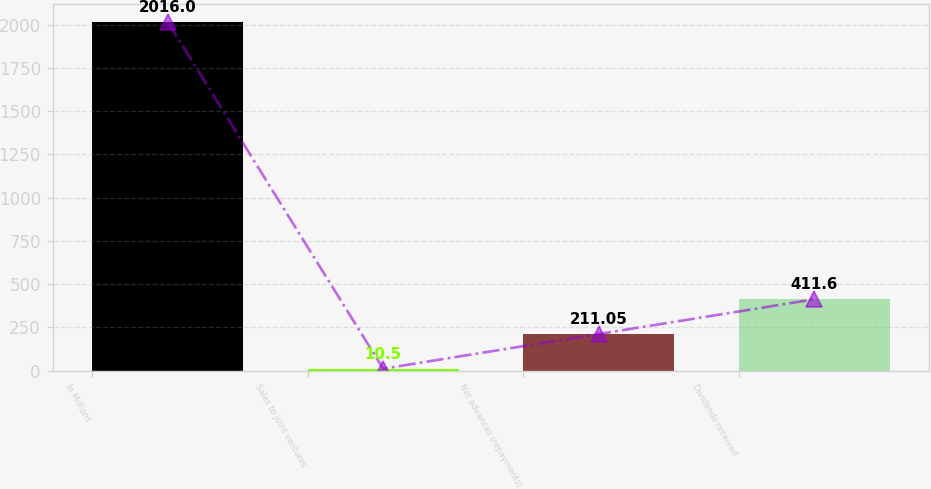Convert chart. <chart><loc_0><loc_0><loc_500><loc_500><bar_chart><fcel>In Millions<fcel>Sales to joint ventures<fcel>Net advances (repayments)<fcel>Dividends received<nl><fcel>2016<fcel>10.5<fcel>211.05<fcel>411.6<nl></chart> 